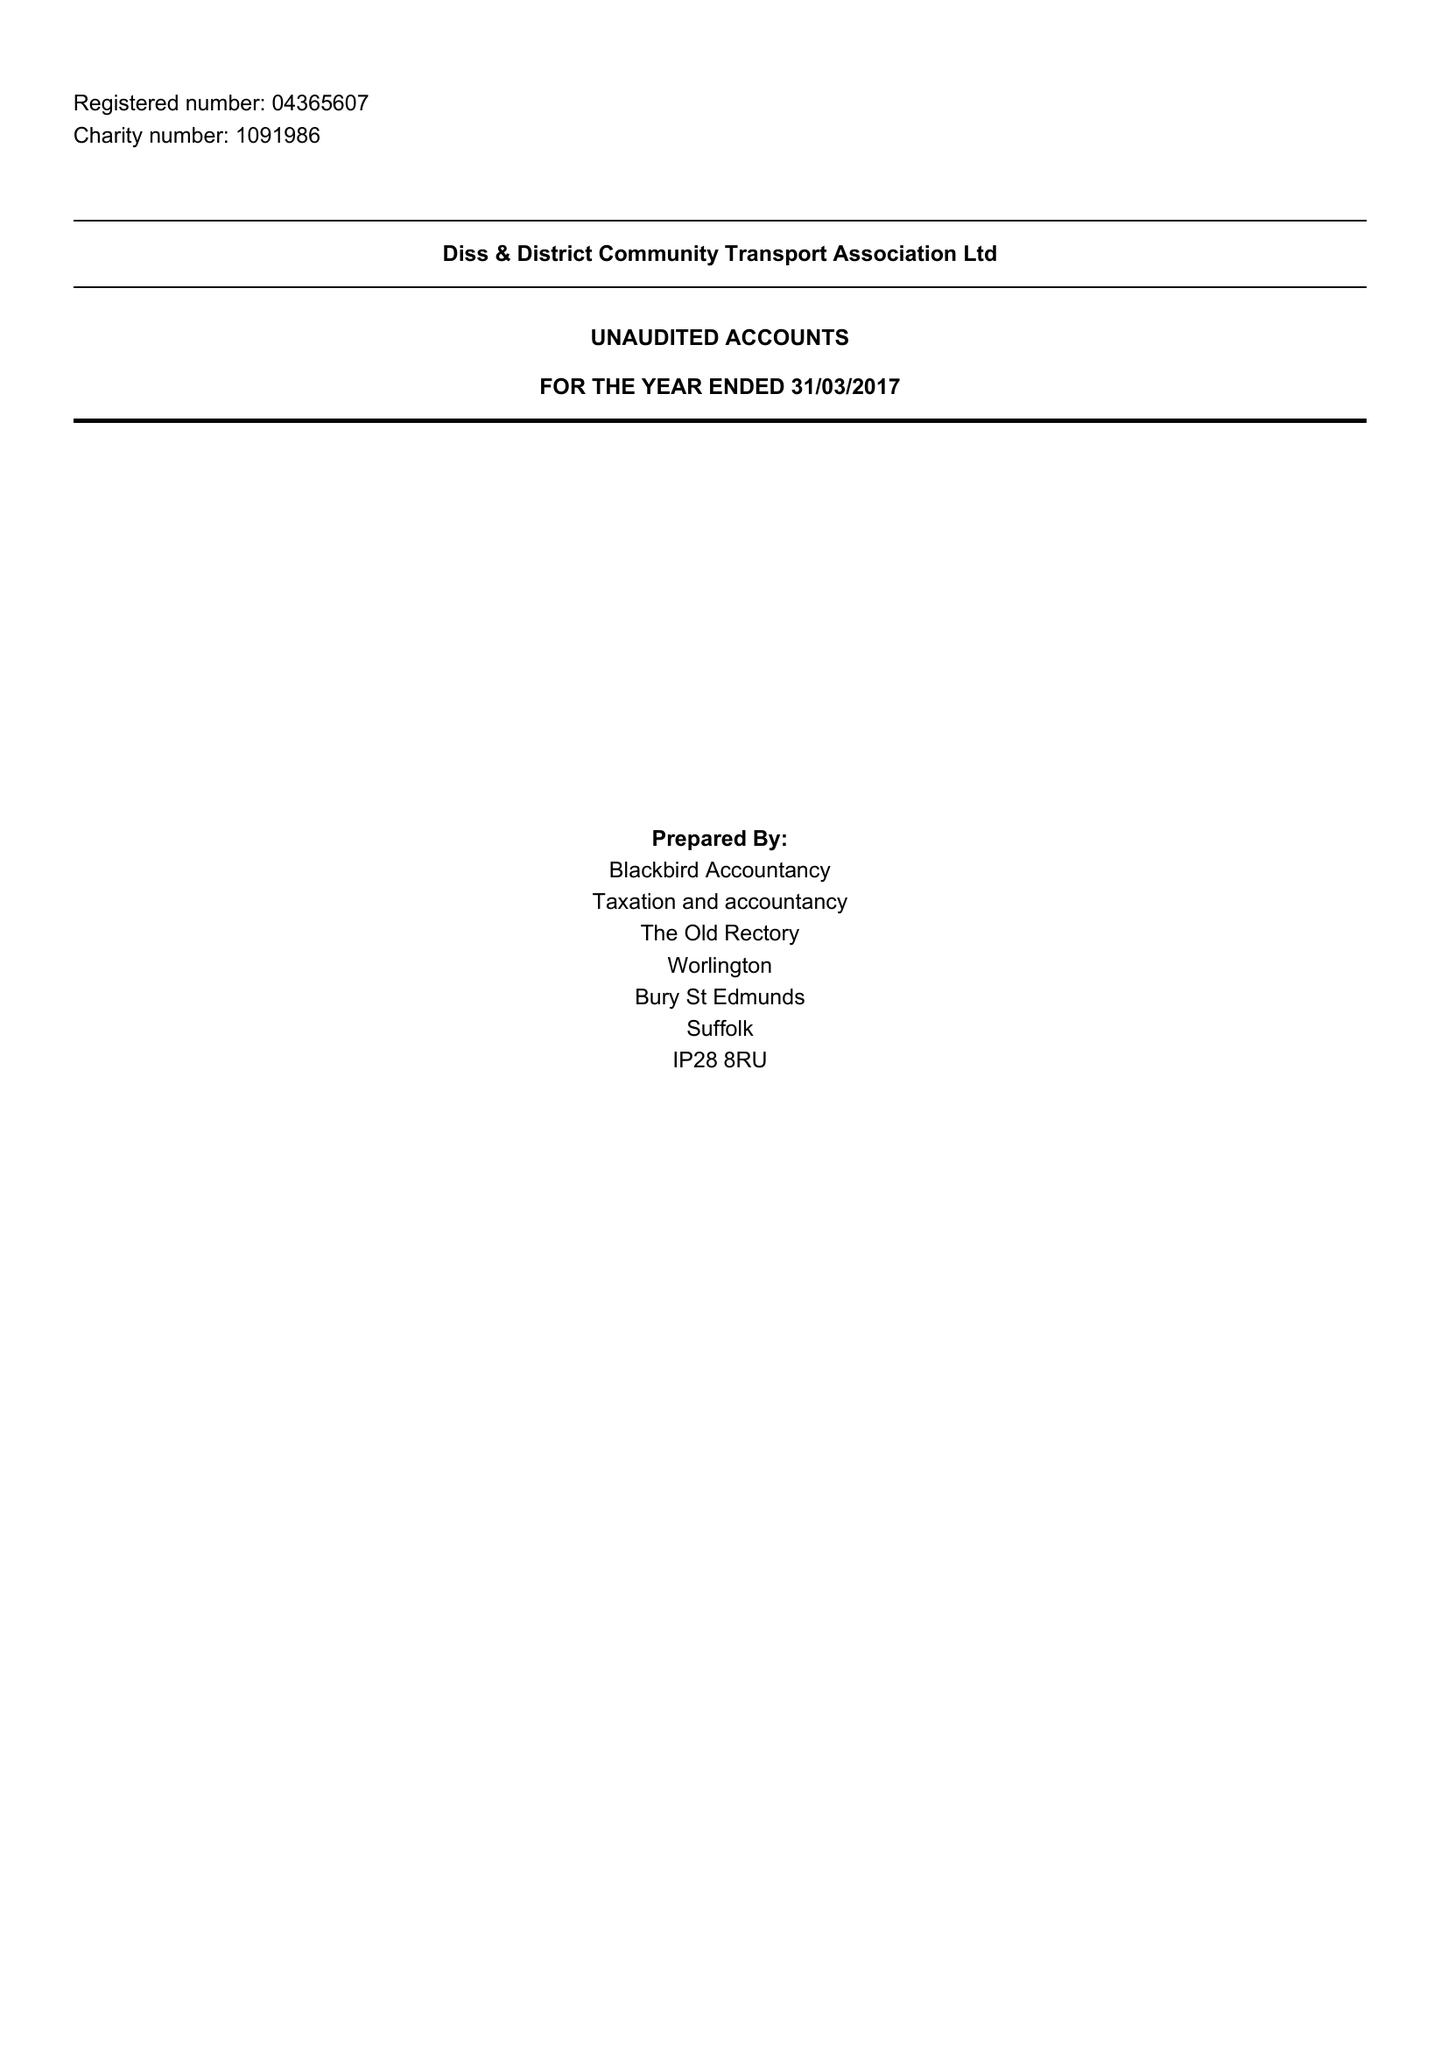What is the value for the address__postcode?
Answer the question using a single word or phrase. IP21 4QD 